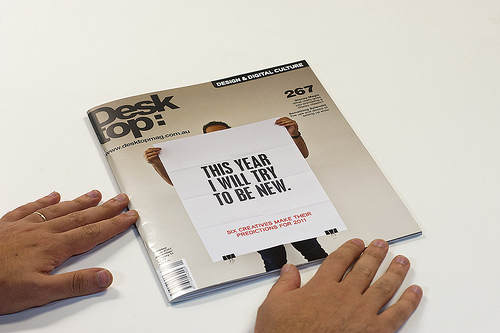<image>
Can you confirm if the person is in front of the magazine? Yes. The person is positioned in front of the magazine, appearing closer to the camera viewpoint. 